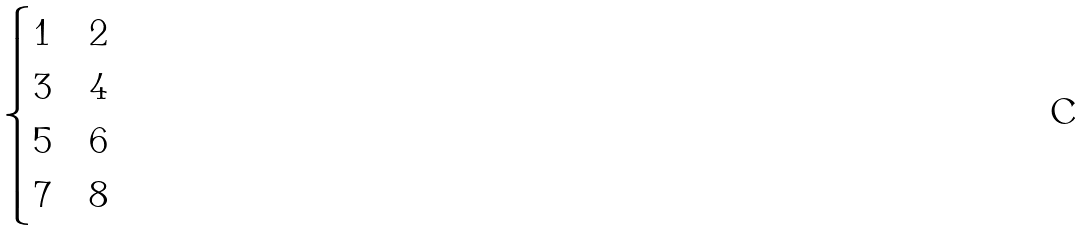<formula> <loc_0><loc_0><loc_500><loc_500>\begin{cases} 1 & \text {2} \\ 3 & \text {4} \\ 5 & \text {6} \\ 7 & \text {8} \\ \end{cases}</formula> 